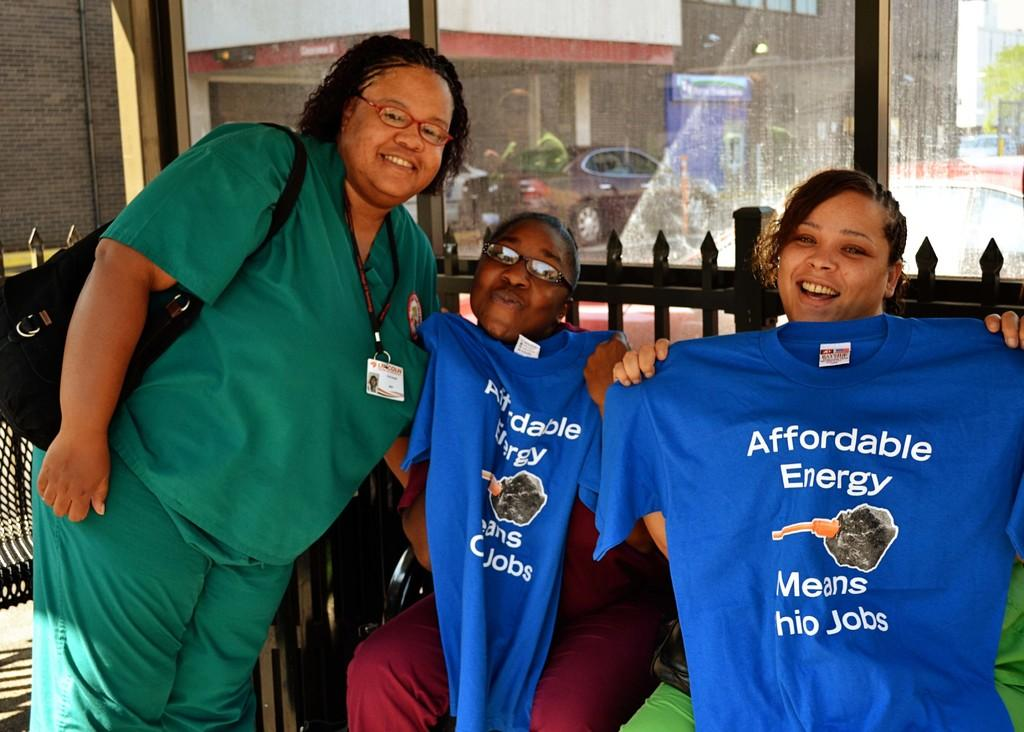<image>
Relay a brief, clear account of the picture shown. A group of women posing with T-shirts in support of affordable energy 